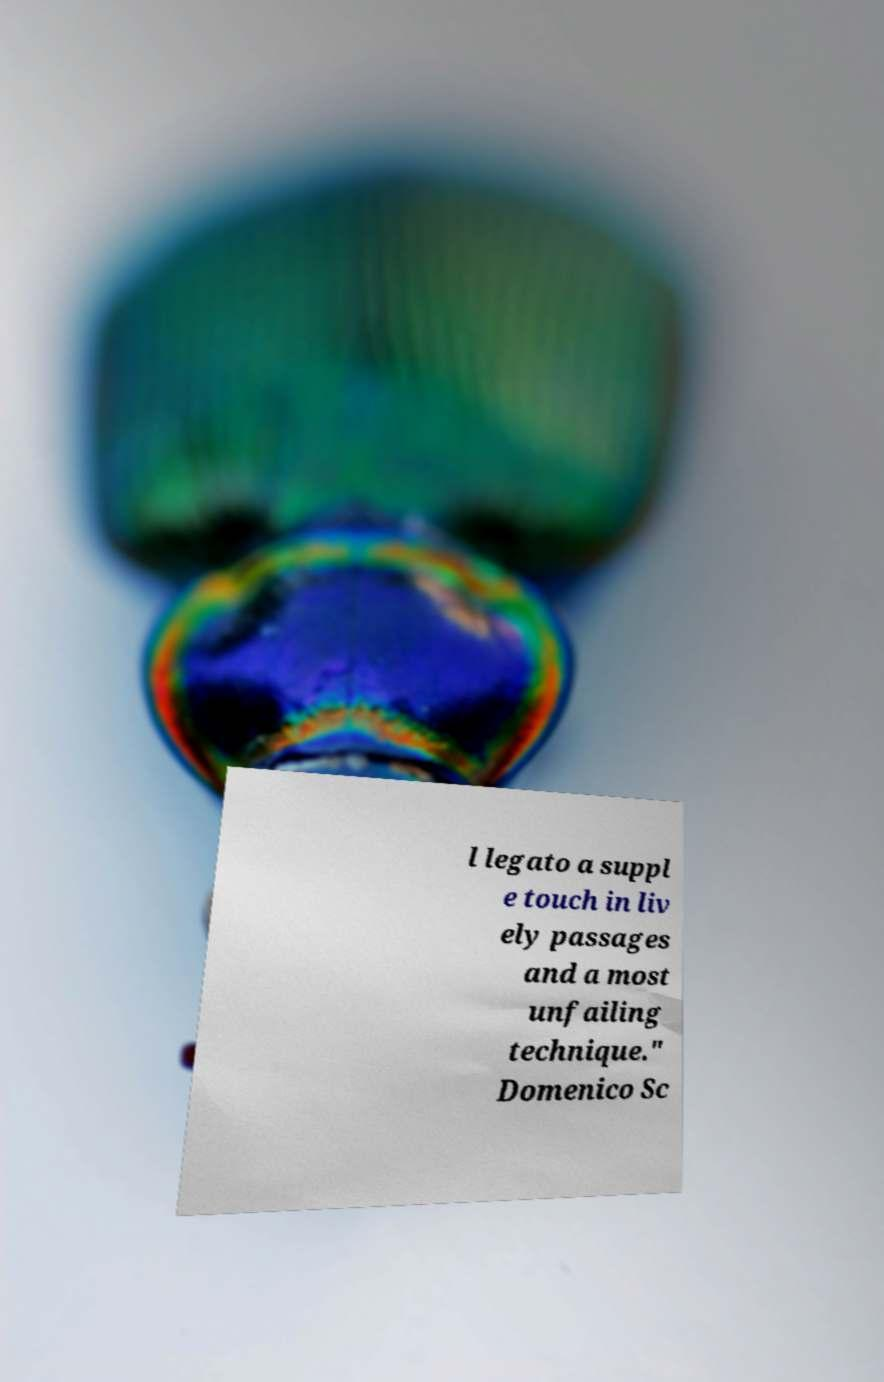Could you assist in decoding the text presented in this image and type it out clearly? l legato a suppl e touch in liv ely passages and a most unfailing technique." Domenico Sc 